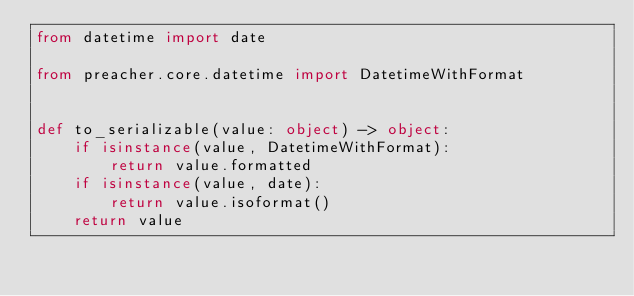<code> <loc_0><loc_0><loc_500><loc_500><_Python_>from datetime import date

from preacher.core.datetime import DatetimeWithFormat


def to_serializable(value: object) -> object:
    if isinstance(value, DatetimeWithFormat):
        return value.formatted
    if isinstance(value, date):
        return value.isoformat()
    return value
</code> 